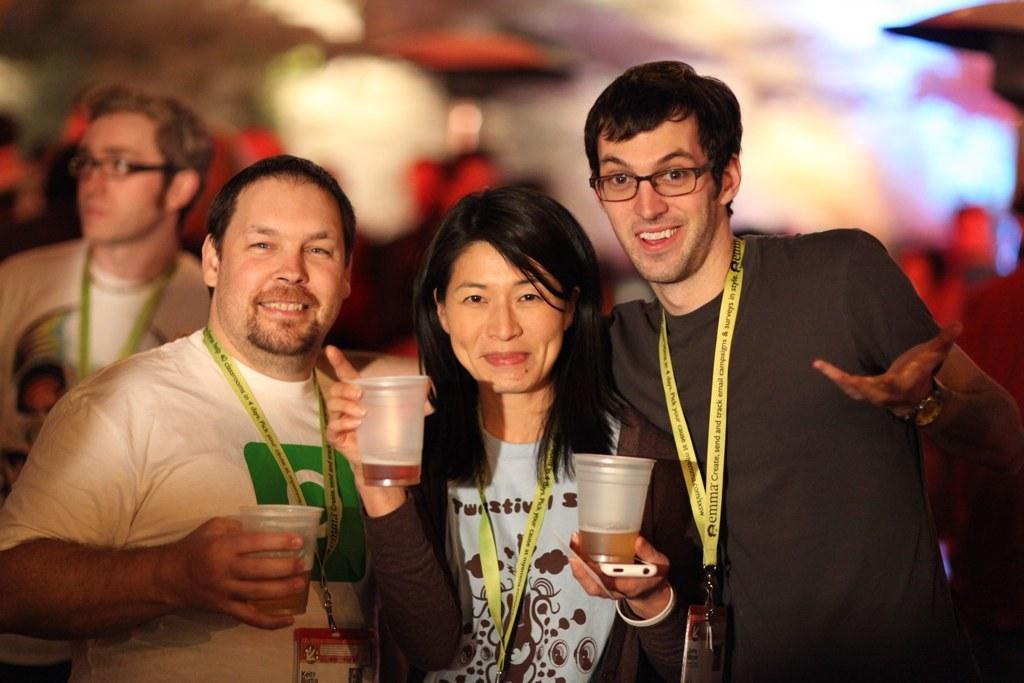What can be observed about the background of the image? The background of the image is blurry. How many people are in the foreground of the image? There are three persons in front of a picture. What are the three persons holding in their hands? The three persons are holding glasses in their hands. What is the facial expression of the three persons? The three persons are smiling. Can you describe the appearance of the other man in the image? The other man is wearing spectacles. What type of engine can be seen in the image? There is no engine present in the image. Can you tell me how the man's throat looks in the image? There is no specific detail about the man's throat visible in the image. 